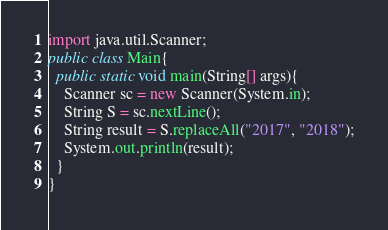<code> <loc_0><loc_0><loc_500><loc_500><_Java_>import java.util.Scanner;
public class Main{
  public static void main(String[] args){
    Scanner sc = new Scanner(System.in);
    String S = sc.nextLine();
    String result = S.replaceAll("2017", "2018");
    System.out.println(result);
  }
}
</code> 